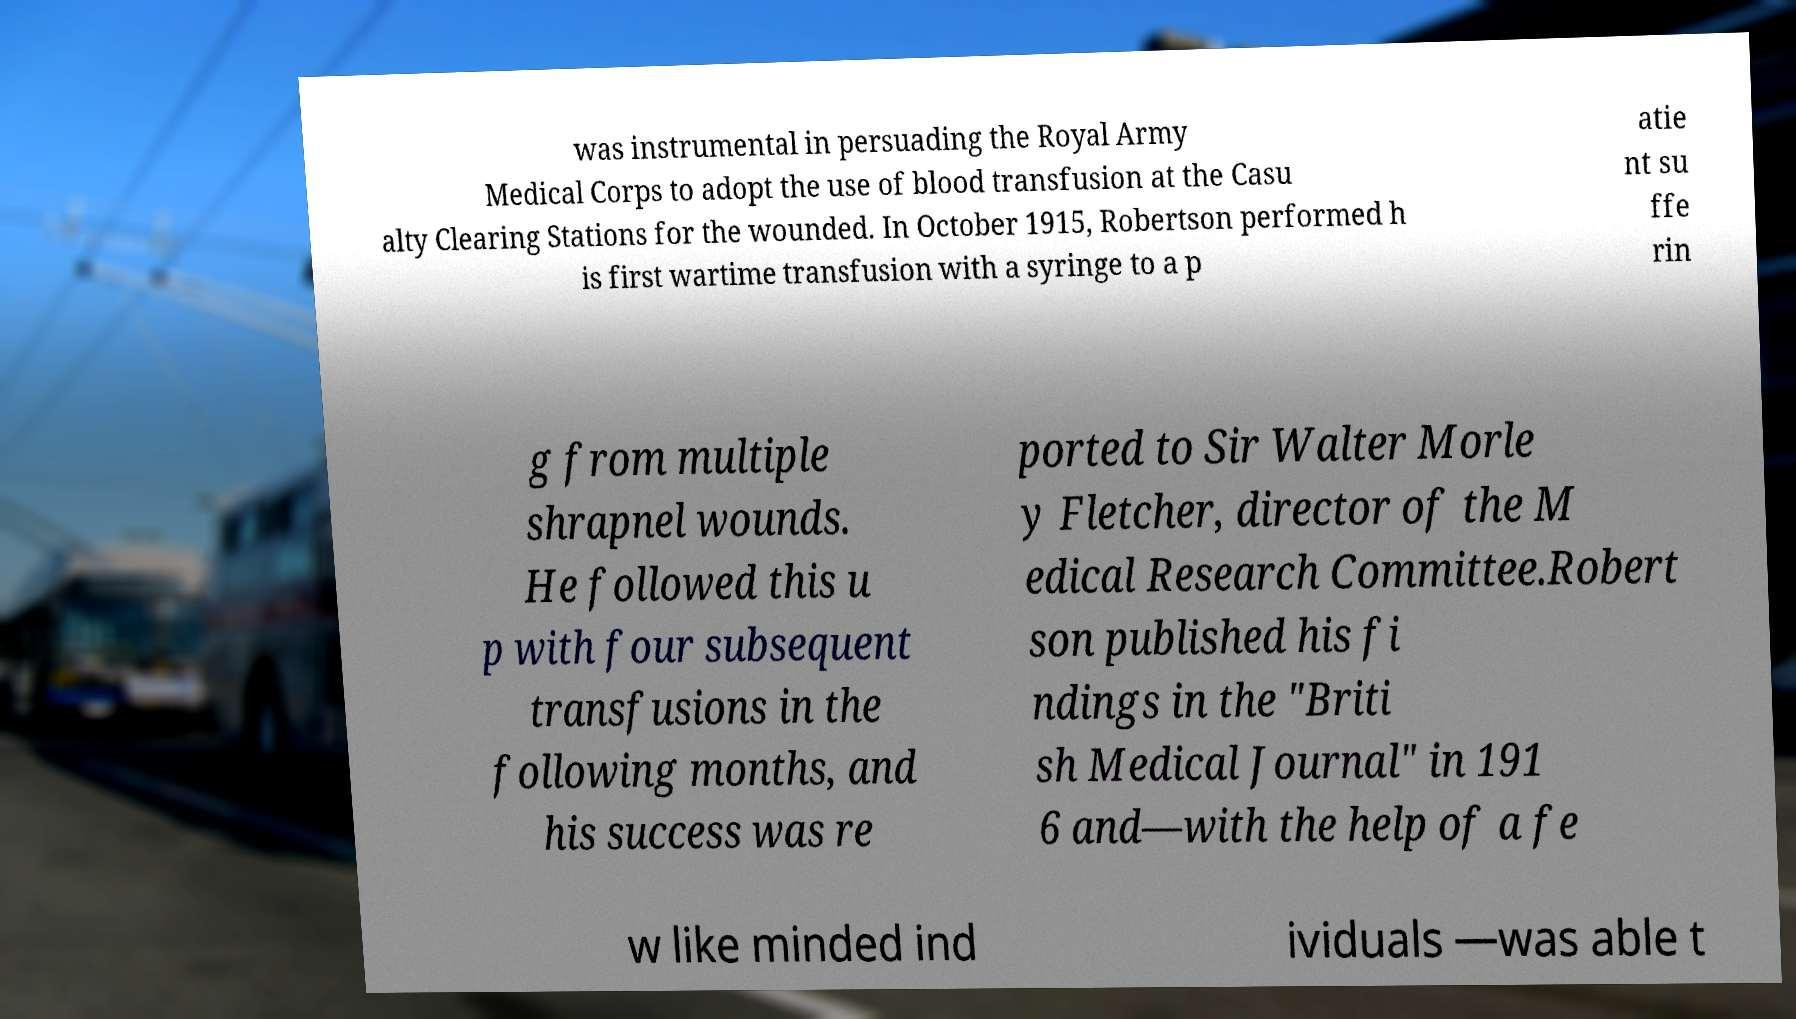Could you extract and type out the text from this image? was instrumental in persuading the Royal Army Medical Corps to adopt the use of blood transfusion at the Casu alty Clearing Stations for the wounded. In October 1915, Robertson performed h is first wartime transfusion with a syringe to a p atie nt su ffe rin g from multiple shrapnel wounds. He followed this u p with four subsequent transfusions in the following months, and his success was re ported to Sir Walter Morle y Fletcher, director of the M edical Research Committee.Robert son published his fi ndings in the "Briti sh Medical Journal" in 191 6 and—with the help of a fe w like minded ind ividuals —was able t 